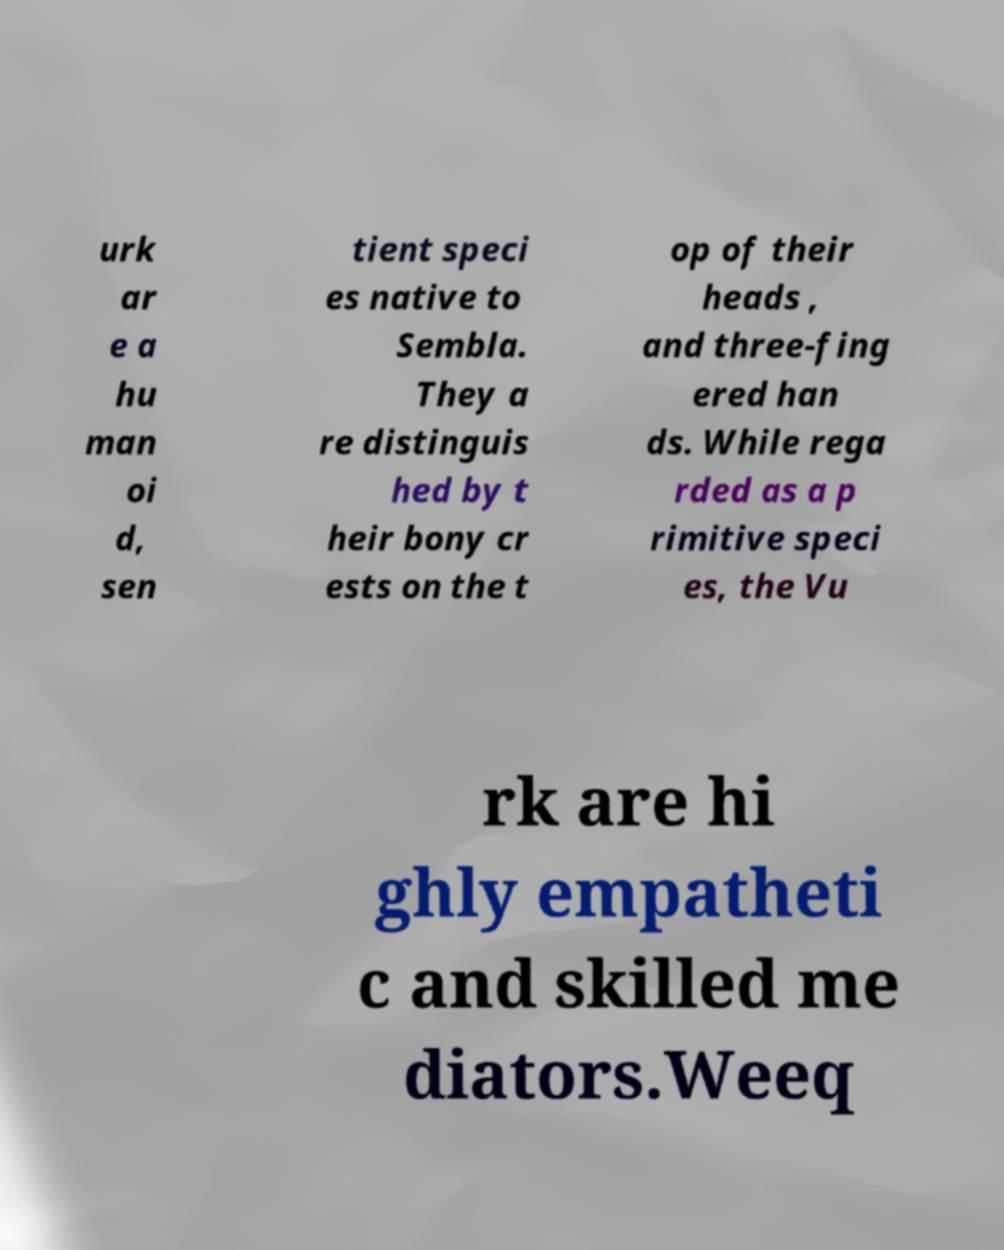What messages or text are displayed in this image? I need them in a readable, typed format. urk ar e a hu man oi d, sen tient speci es native to Sembla. They a re distinguis hed by t heir bony cr ests on the t op of their heads , and three-fing ered han ds. While rega rded as a p rimitive speci es, the Vu rk are hi ghly empatheti c and skilled me diators.Weeq 